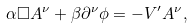<formula> <loc_0><loc_0><loc_500><loc_500>\alpha \Box A ^ { \nu } + \beta \partial ^ { \nu } \phi = - V ^ { \prime } A ^ { \nu } ,</formula> 